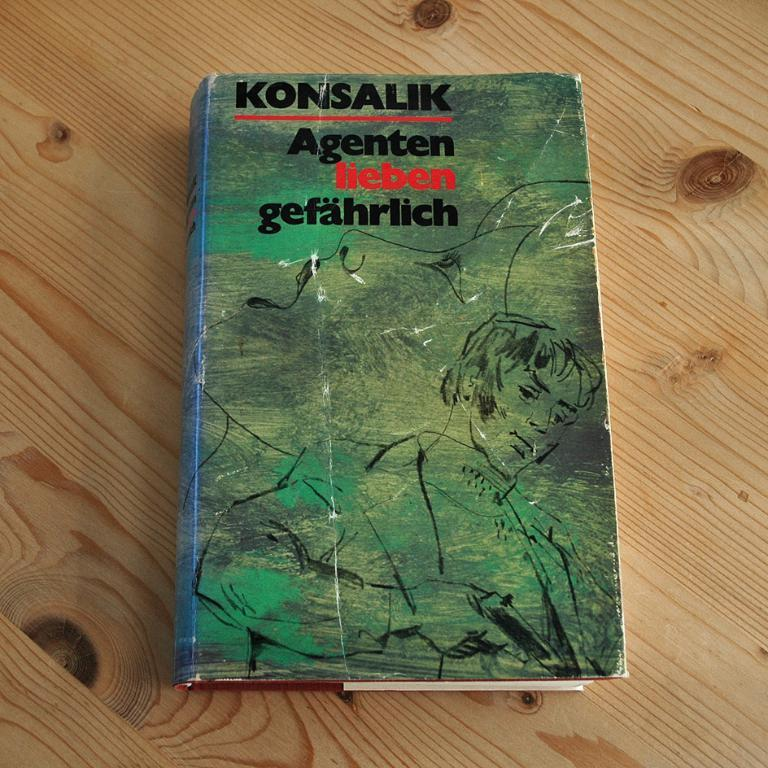<image>
Relay a brief, clear account of the picture shown. The book Agenten lieben gefahrlich by Konsalik sits on a wood surface 